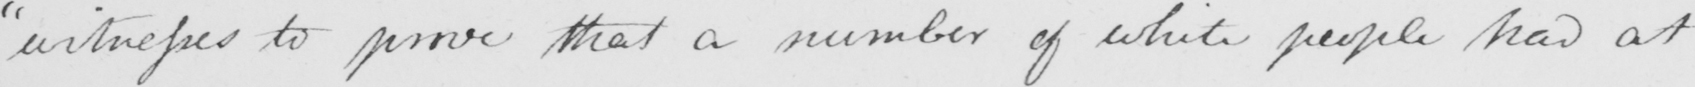Please provide the text content of this handwritten line. " witnesses to prove that a number of white people had at 